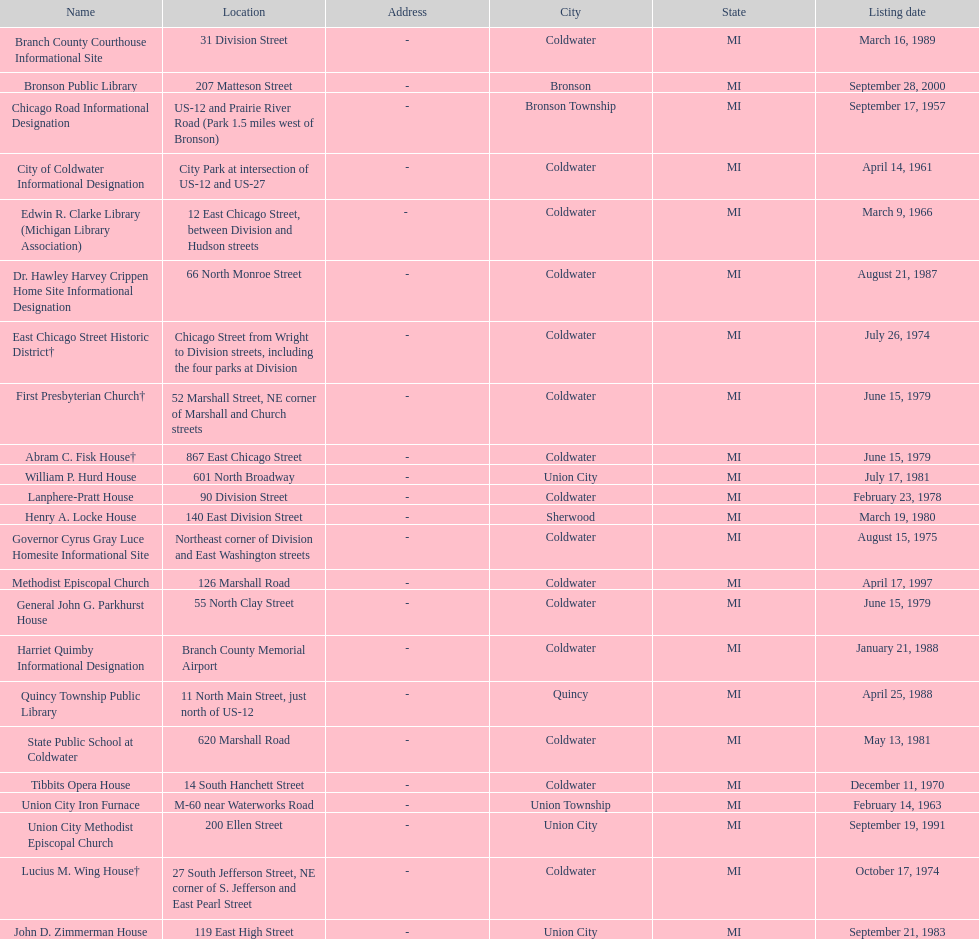How many historic sites are listed in coldwater? 15. 